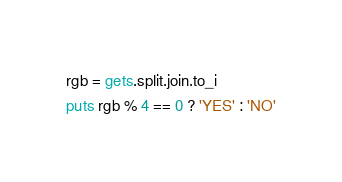<code> <loc_0><loc_0><loc_500><loc_500><_Ruby_>rgb = gets.split.join.to_i
puts rgb % 4 == 0 ? 'YES' : 'NO'
</code> 